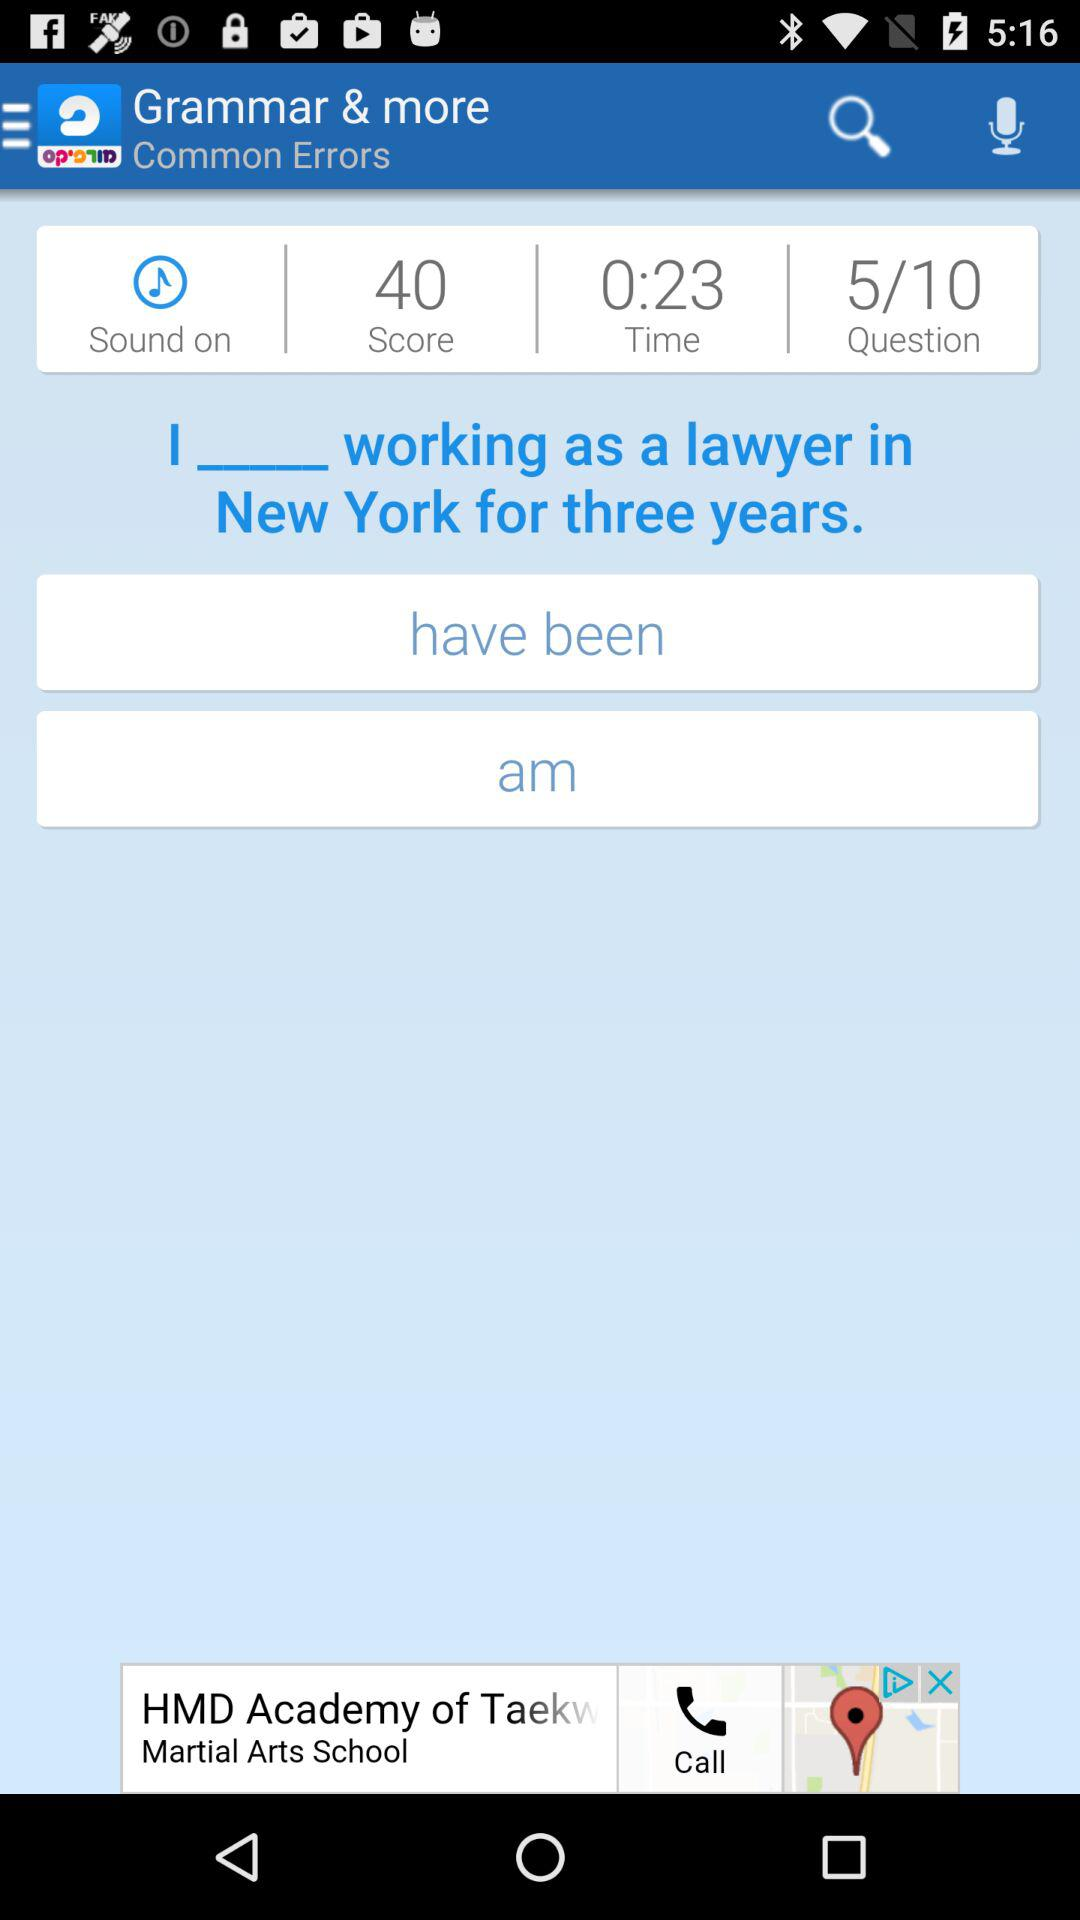How many questions are available? There are 10 questions available. 